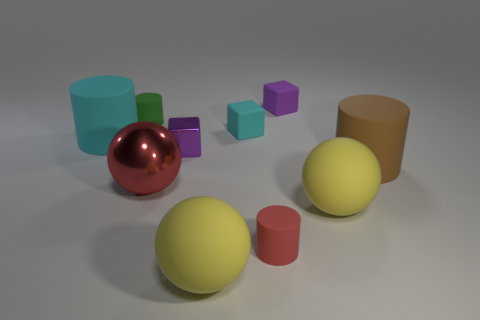What is the shape of the tiny cyan rubber object?
Make the answer very short. Cube. Are there an equal number of big red balls right of the red ball and matte cylinders on the right side of the tiny cyan rubber cube?
Offer a very short reply. No. Do the tiny thing to the left of the large red shiny object and the tiny cube that is behind the small green cylinder have the same color?
Provide a short and direct response. No. Is the number of blocks that are to the left of the red matte thing greater than the number of red shiny things?
Keep it short and to the point. Yes. There is a tiny purple object that is made of the same material as the green cylinder; what shape is it?
Make the answer very short. Cube. Do the matte cylinder that is in front of the metallic ball and the big red shiny object have the same size?
Keep it short and to the point. No. What shape is the cyan rubber object that is right of the large object to the left of the green object?
Keep it short and to the point. Cube. What is the size of the red thing that is on the right side of the small purple block that is left of the tiny cyan thing?
Provide a short and direct response. Small. There is a big cylinder right of the big cyan object; what is its color?
Give a very brief answer. Brown. There is a green cylinder that is made of the same material as the tiny red thing; what is its size?
Offer a very short reply. Small. 